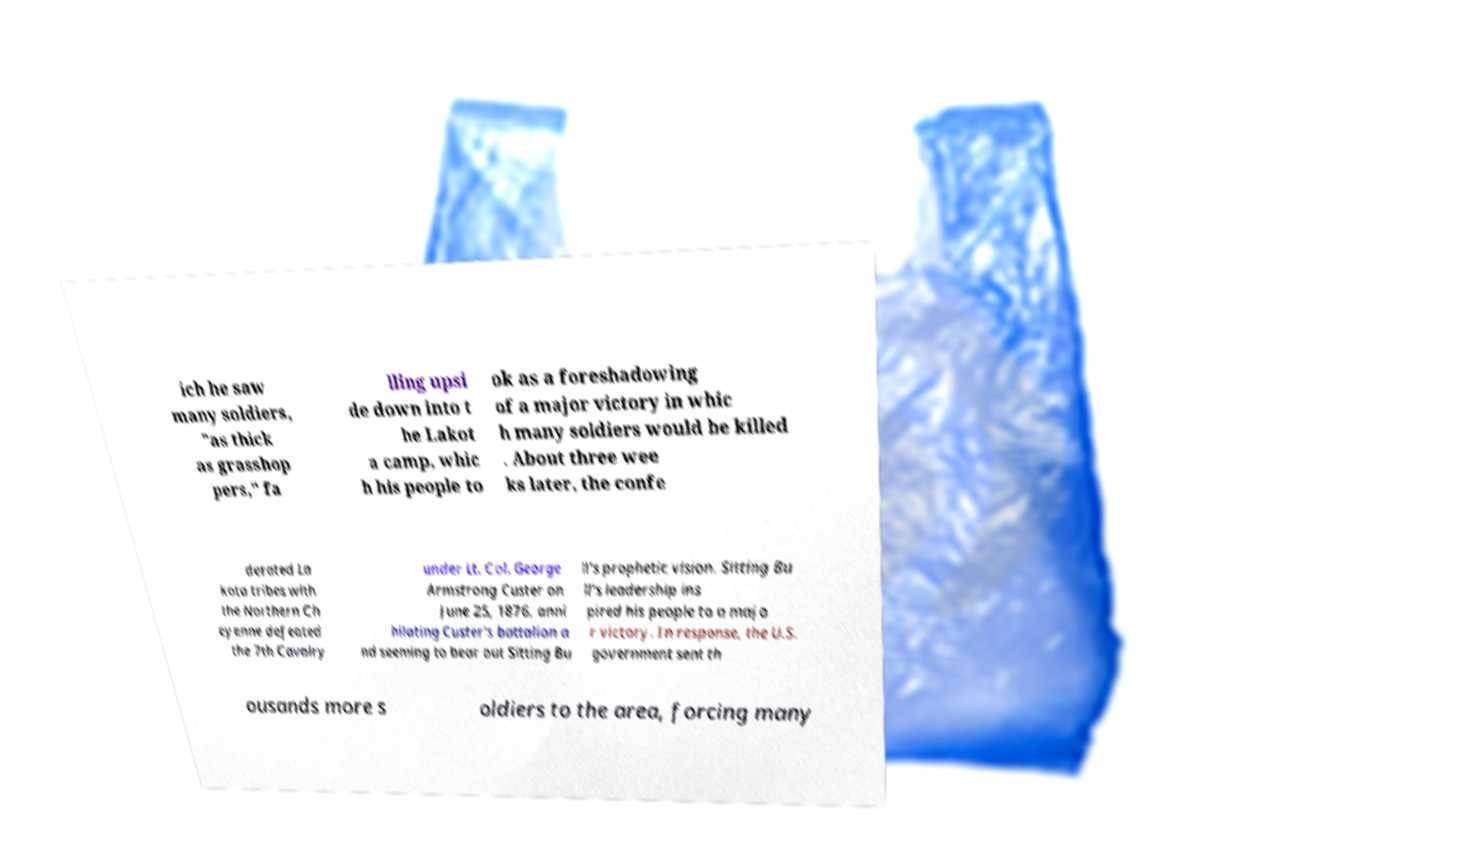There's text embedded in this image that I need extracted. Can you transcribe it verbatim? ich he saw many soldiers, "as thick as grasshop pers," fa lling upsi de down into t he Lakot a camp, whic h his people to ok as a foreshadowing of a major victory in whic h many soldiers would be killed . About three wee ks later, the confe derated La kota tribes with the Northern Ch eyenne defeated the 7th Cavalry under Lt. Col. George Armstrong Custer on June 25, 1876, anni hilating Custer's battalion a nd seeming to bear out Sitting Bu ll's prophetic vision. Sitting Bu ll's leadership ins pired his people to a majo r victory. In response, the U.S. government sent th ousands more s oldiers to the area, forcing many 